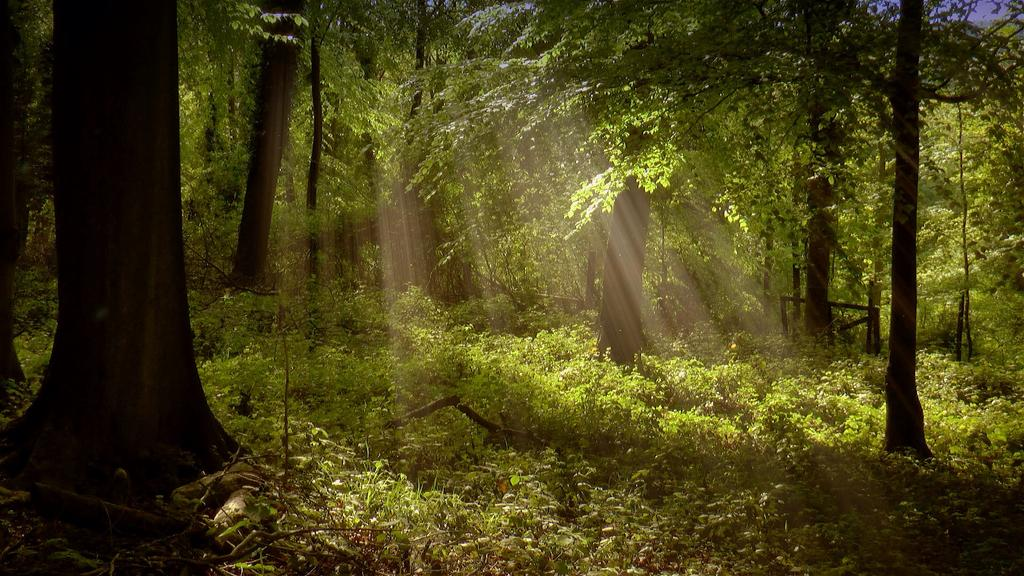Where was the picture taken? The picture was clicked outside. What can be seen in the foreground of the image? There are plants in the foreground of the image. What can be seen in the background of the image? There are trees and wooden objects in the background of the image. Can you see any lawyers in the image? There are no lawyers present in the image. What type of headwear is the airport wearing in the image? There is no airport or headwear present in the image. 